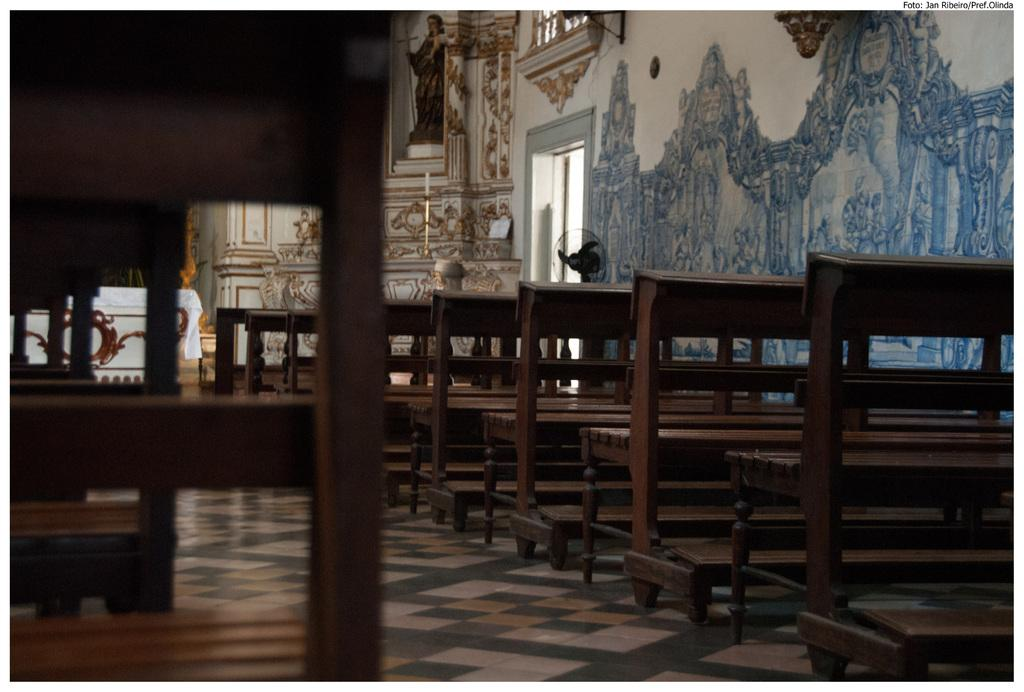What type of seating is located in the center of the image? There are benches in the center of the image. What can be seen in the background of the image? There is a statue and some artwork on the wall in the background of the image. What type of leather is used to make the cabbage in the image? There is no cabbage present in the image, and therefore no leather or substance can be associated with it. 